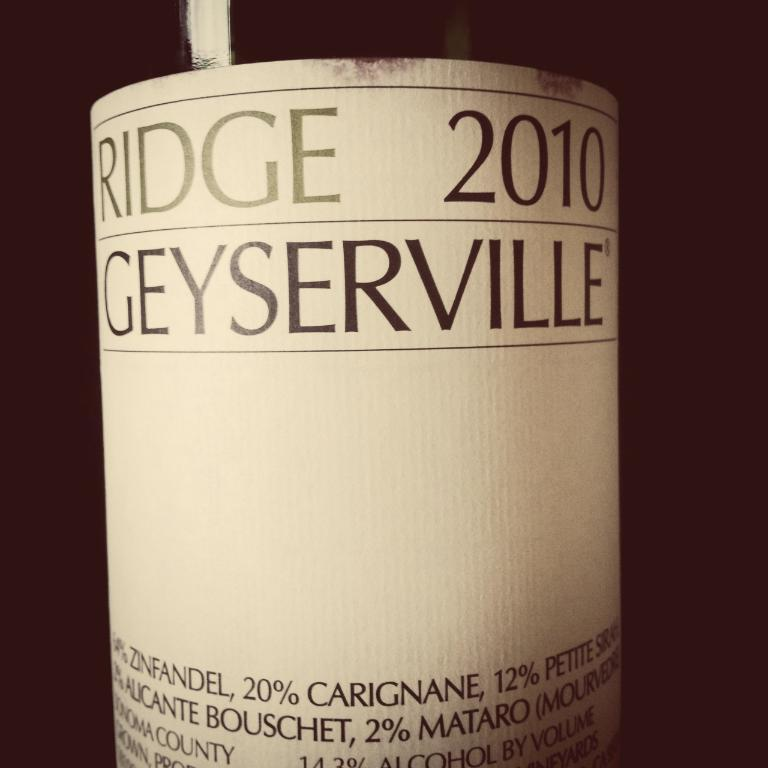<image>
Give a short and clear explanation of the subsequent image. a white label on a bottle of ridge 2010 geyerville 